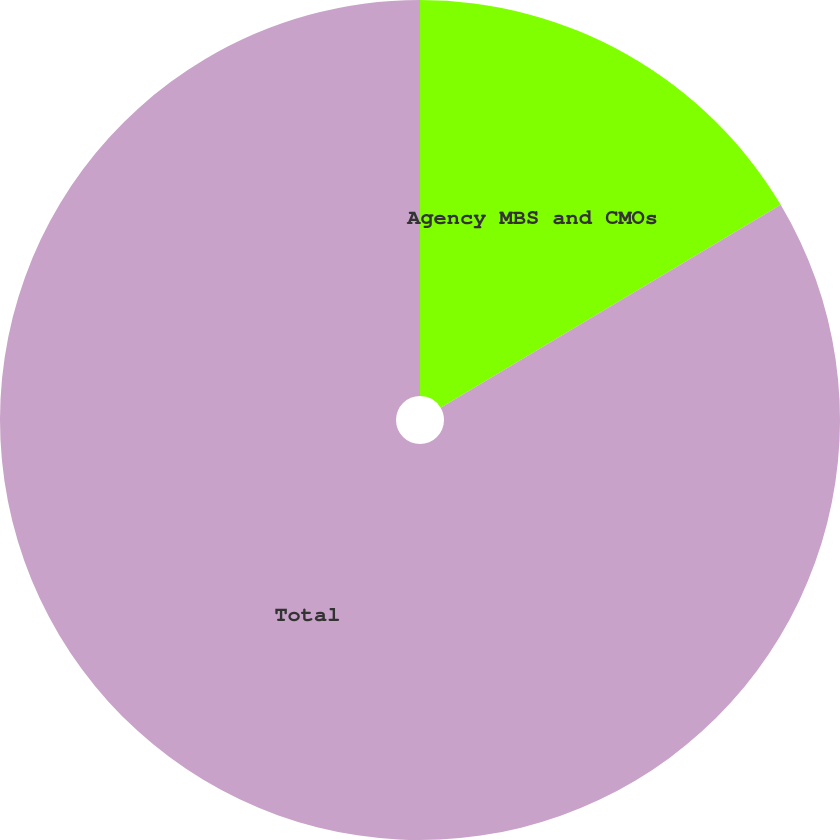Convert chart to OTSL. <chart><loc_0><loc_0><loc_500><loc_500><pie_chart><fcel>Agency MBS and CMOs<fcel>Total<nl><fcel>16.44%<fcel>83.56%<nl></chart> 